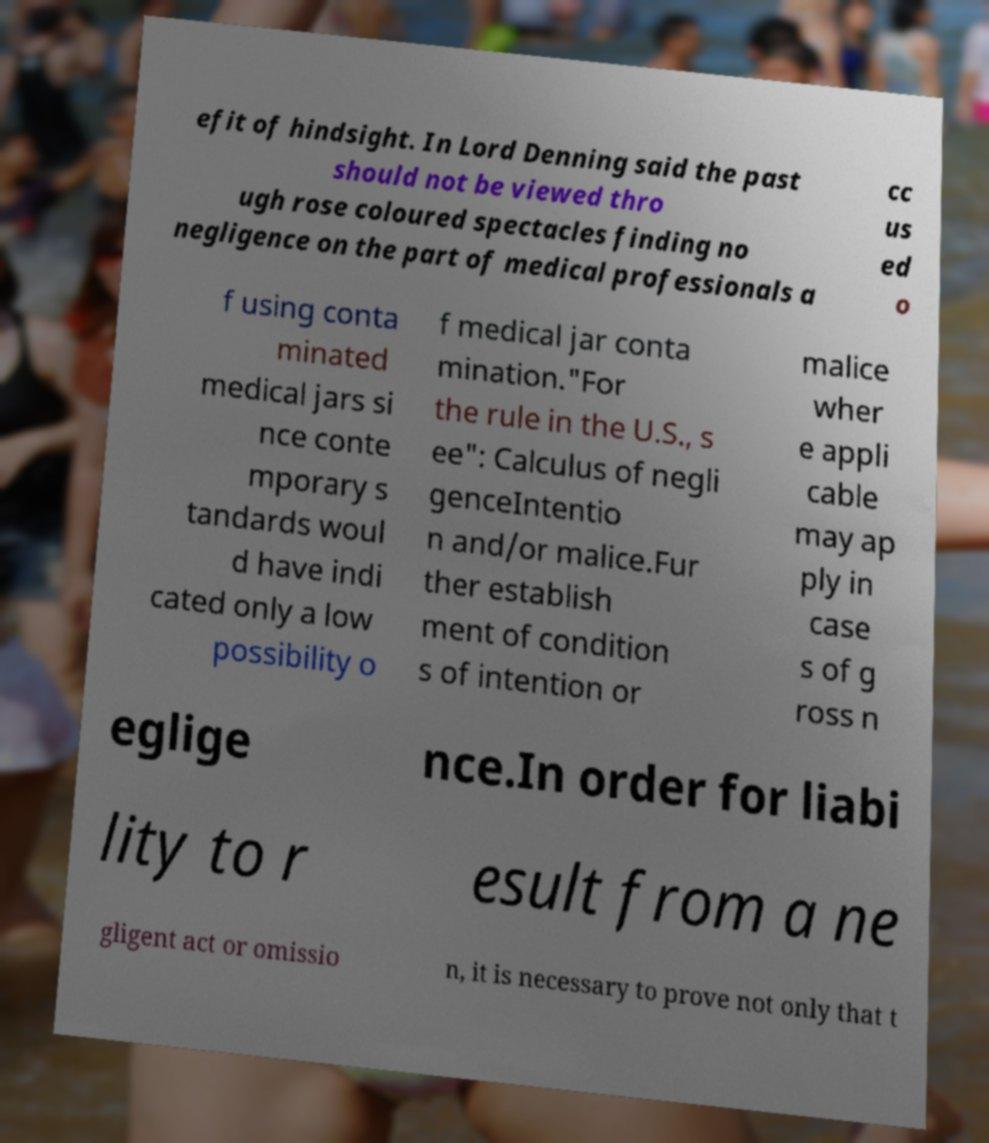For documentation purposes, I need the text within this image transcribed. Could you provide that? efit of hindsight. In Lord Denning said the past should not be viewed thro ugh rose coloured spectacles finding no negligence on the part of medical professionals a cc us ed o f using conta minated medical jars si nce conte mporary s tandards woul d have indi cated only a low possibility o f medical jar conta mination."For the rule in the U.S., s ee": Calculus of negli genceIntentio n and/or malice.Fur ther establish ment of condition s of intention or malice wher e appli cable may ap ply in case s of g ross n eglige nce.In order for liabi lity to r esult from a ne gligent act or omissio n, it is necessary to prove not only that t 